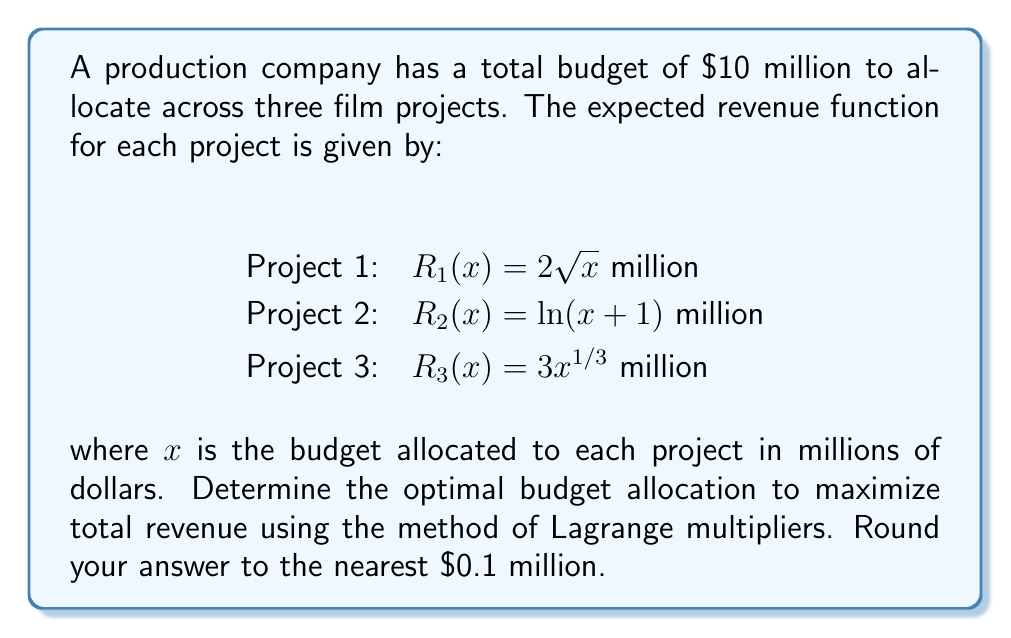Help me with this question. To solve this optimization problem using the method of Lagrange multipliers:

1) Define the objective function:
   $f(x,y,z) = 2\sqrt{x} + \ln(y+1) + 3z^{1/3}$

2) Define the constraint:
   $g(x,y,z) = x + y + z - 10 = 0$

3) Form the Lagrangian:
   $L(x,y,z,\lambda) = 2\sqrt{x} + \ln(y+1) + 3z^{1/3} - \lambda(x + y + z - 10)$

4) Set partial derivatives equal to zero:

   $\frac{\partial L}{\partial x} = \frac{1}{\sqrt{x}} - \lambda = 0$
   $\frac{\partial L}{\partial y} = \frac{1}{y+1} - \lambda = 0$
   $\frac{\partial L}{\partial z} = z^{-2/3} - \lambda = 0$
   $\frac{\partial L}{\partial \lambda} = x + y + z - 10 = 0$

5) From these equations:
   $x = \frac{1}{\lambda^2}$
   $y = \frac{1}{\lambda} - 1$
   $z = \frac{1}{\lambda^3}$

6) Substitute into the constraint equation:
   $\frac{1}{\lambda^2} + (\frac{1}{\lambda} - 1) + \frac{1}{\lambda^3} = 10$

7) Solve this equation numerically to get $\lambda \approx 0.5858$

8) Substitute back to get the optimal allocations:
   $x \approx 2.9$ million
   $y \approx 0.7$ million
   $z \approx 6.4$ million

Rounding to the nearest 0.1 million gives the final answer.
Answer: $2.9, 0.7, 6.4$ million 